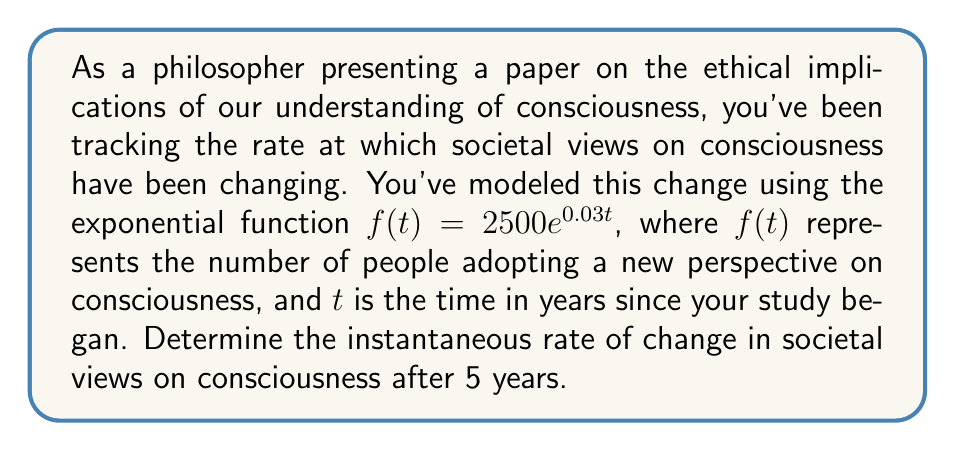Show me your answer to this math problem. To solve this problem, we need to find the derivative of the given function and evaluate it at $t=5$. This will give us the instantaneous rate of change at that point in time.

1) The given function is $f(t) = 2500e^{0.03t}$

2) To find the derivative, we use the chain rule:
   $$f'(t) = 2500 \cdot 0.03 \cdot e^{0.03t}$$
   $$f'(t) = 75e^{0.03t}$$

3) Now, we need to evaluate this at $t=5$:
   $$f'(5) = 75e^{0.03 \cdot 5}$$
   $$f'(5) = 75e^{0.15}$$

4) Using a calculator or approximating:
   $$f'(5) \approx 75 \cdot 1.1618 \approx 87.135$$

This result represents the instantaneous rate of change in the number of people adopting the new perspective on consciousness after 5 years.
Answer: The instantaneous rate of change in societal views on consciousness after 5 years is approximately 87.135 people per year. 